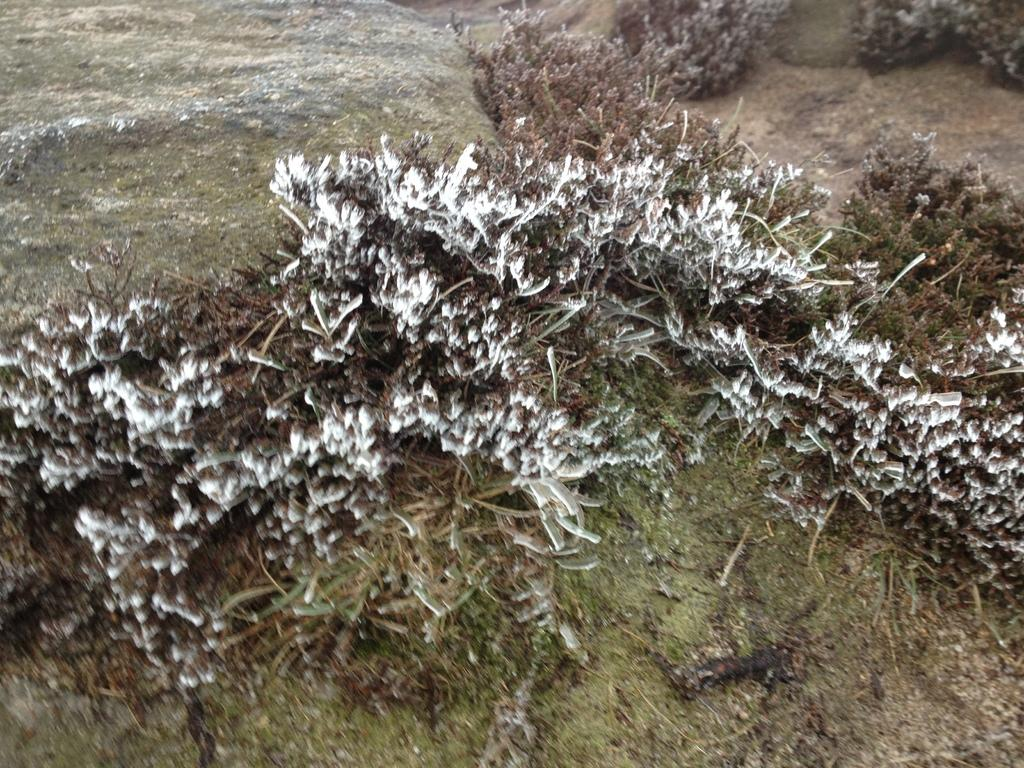What type of vegetation can be seen in the image? There are bushes in the image. Are there any objects placed on the bushes? Yes, there are white-colored objects on the bushes. What type of waste can be seen on the street in the image? There is no street or waste present in the image; it only features bushes with white-colored objects on them. 